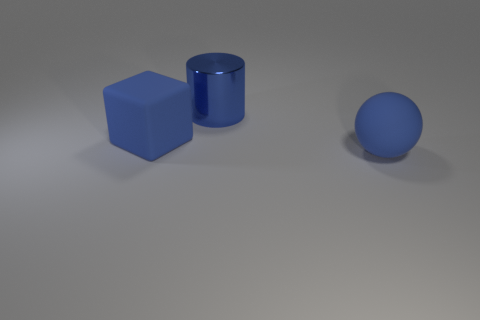Are there any other things that have the same material as the large cylinder?
Offer a terse response. No. The large shiny thing that is the same color as the big block is what shape?
Your answer should be very brief. Cylinder. What size is the ball that is the same material as the blue block?
Your answer should be very brief. Large. Is there a tiny metal cylinder that has the same color as the sphere?
Provide a succinct answer. No. How many things are blue spheres or large matte things left of the metallic cylinder?
Make the answer very short. 2. Is the number of blue matte objects greater than the number of large green cylinders?
Provide a short and direct response. Yes. The matte sphere that is the same color as the large shiny cylinder is what size?
Offer a very short reply. Large. Is there a blue cylinder that has the same material as the blue ball?
Your response must be concise. No. The big thing that is in front of the big blue metal cylinder and to the left of the large blue ball has what shape?
Keep it short and to the point. Cube. How big is the blue cube?
Your answer should be very brief. Large. 